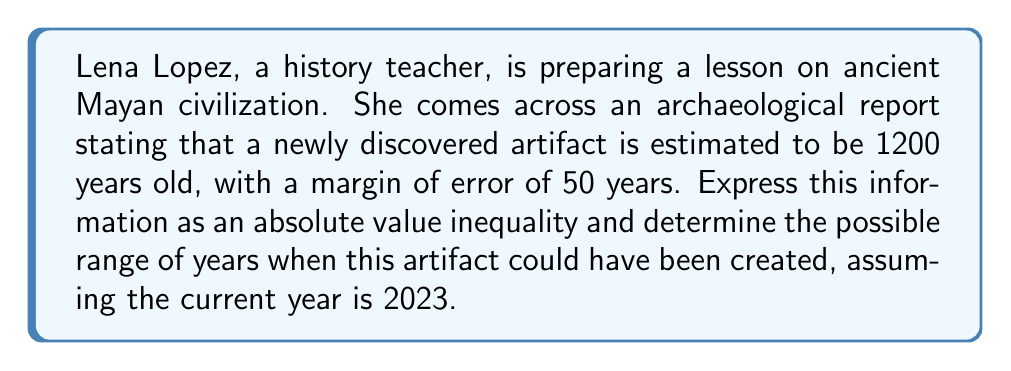Show me your answer to this math problem. Let's approach this step-by-step:

1) First, we need to set up our inequality. Let $x$ represent the actual age of the artifact in years. The estimate is 1200 years, with a margin of error of 50 years. This can be expressed as:

   $$|x - 1200| \leq 50$$

2) To solve this inequality, we need to consider both sides of the absolute value:

   $$-50 \leq x - 1200 \leq 50$$

3) Now, let's solve for $x$ by adding 1200 to all parts of the inequality:

   $$1150 \leq x \leq 1250$$

4) This tells us that the artifact is between 1150 and 1250 years old.

5) To find the year range when the artifact could have been created, we need to subtract these ages from the current year (2023):

   For 1250 years ago: $2023 - 1250 = 773$ CE
   For 1150 years ago: $2023 - 1150 = 873$ CE

Therefore, the artifact could have been created between 773 CE and 873 CE.
Answer: The absolute value inequality is $|x - 1200| \leq 50$, where $x$ is the actual age of the artifact in years. The artifact could have been created between 773 CE and 873 CE. 